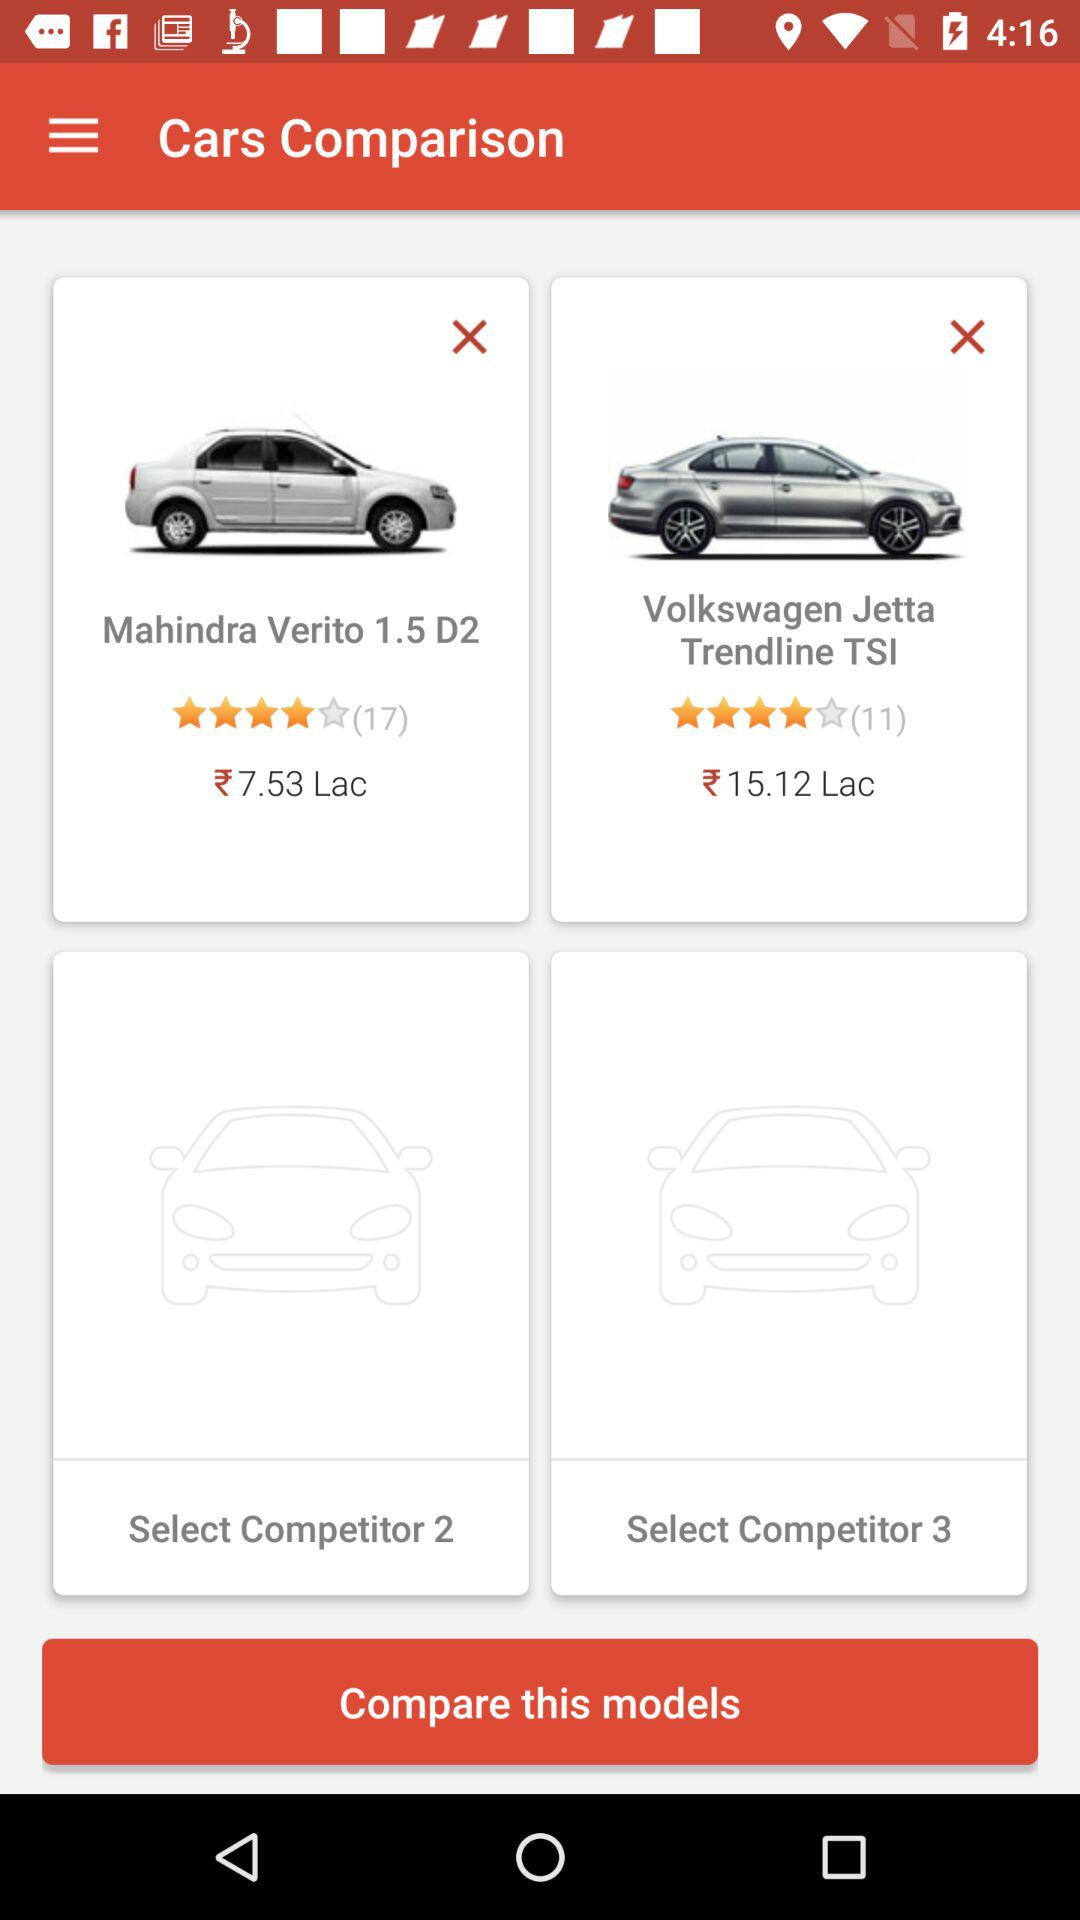What is the rating of "Mahindra Verito 1.5 D2"? The rating is 4 stars. 